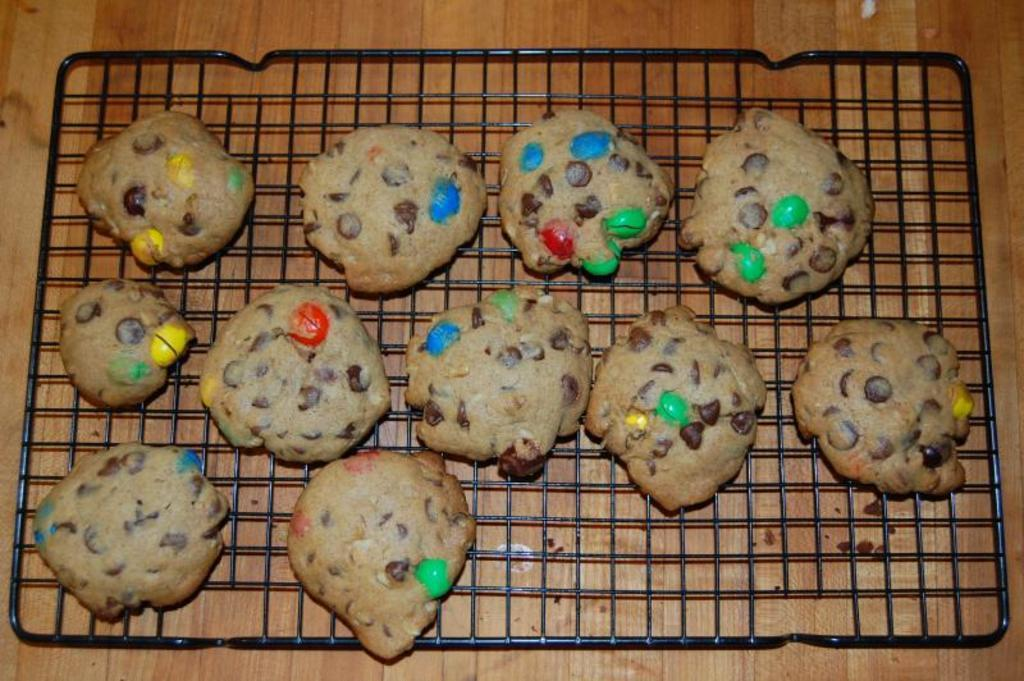What type of food can be seen in the image? There are cookies in the image. Where are the cookies placed? The cookies are on a grill. On what surface is the grill located? The grill is on a table. What songs are being performed on the stage in the image? There is no stage or songs present in the image; it features cookies on a grill. 